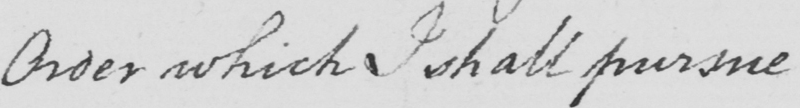What does this handwritten line say? Order which I shall pursue 